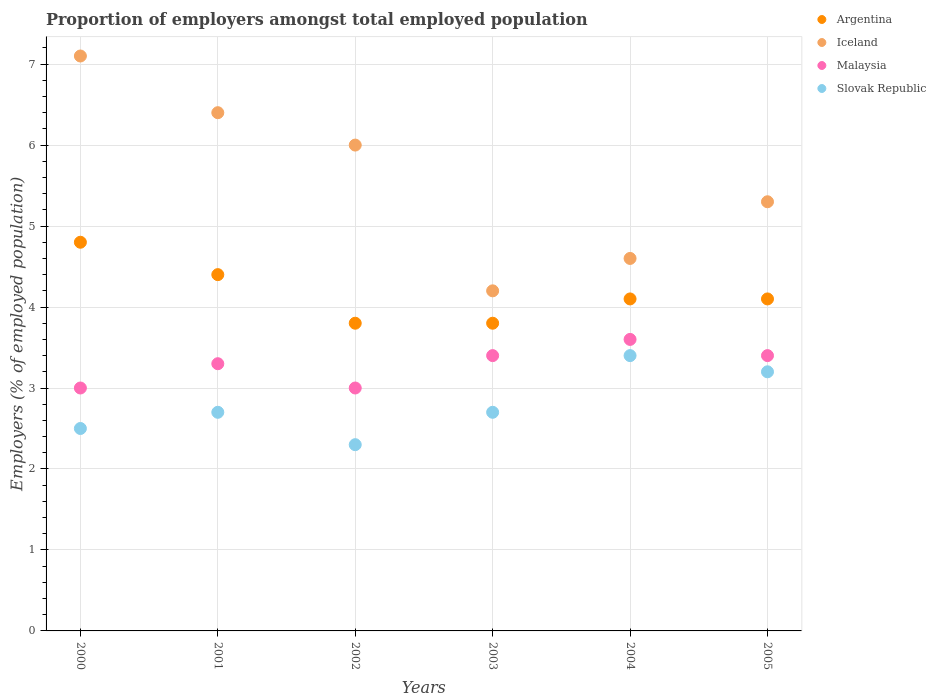Is the number of dotlines equal to the number of legend labels?
Make the answer very short. Yes. What is the proportion of employers in Slovak Republic in 2000?
Provide a short and direct response. 2.5. Across all years, what is the maximum proportion of employers in Slovak Republic?
Give a very brief answer. 3.4. Across all years, what is the minimum proportion of employers in Malaysia?
Offer a very short reply. 3. In which year was the proportion of employers in Iceland maximum?
Your response must be concise. 2000. What is the total proportion of employers in Iceland in the graph?
Give a very brief answer. 33.6. What is the difference between the proportion of employers in Argentina in 2000 and that in 2002?
Provide a succinct answer. 1. What is the difference between the proportion of employers in Iceland in 2000 and the proportion of employers in Argentina in 2001?
Your response must be concise. 2.7. What is the average proportion of employers in Malaysia per year?
Your answer should be compact. 3.28. In the year 2003, what is the difference between the proportion of employers in Slovak Republic and proportion of employers in Iceland?
Your response must be concise. -1.5. In how many years, is the proportion of employers in Slovak Republic greater than 2 %?
Provide a short and direct response. 6. What is the ratio of the proportion of employers in Argentina in 2001 to that in 2005?
Provide a short and direct response. 1.07. Is the proportion of employers in Iceland in 2002 less than that in 2004?
Give a very brief answer. No. What is the difference between the highest and the second highest proportion of employers in Argentina?
Your response must be concise. 0.4. What is the difference between the highest and the lowest proportion of employers in Iceland?
Make the answer very short. 2.9. Is the sum of the proportion of employers in Malaysia in 2001 and 2003 greater than the maximum proportion of employers in Iceland across all years?
Make the answer very short. No. Does the proportion of employers in Iceland monotonically increase over the years?
Provide a succinct answer. No. How many dotlines are there?
Your answer should be very brief. 4. Are the values on the major ticks of Y-axis written in scientific E-notation?
Your response must be concise. No. Does the graph contain any zero values?
Your answer should be very brief. No. Does the graph contain grids?
Offer a very short reply. Yes. What is the title of the graph?
Ensure brevity in your answer.  Proportion of employers amongst total employed population. What is the label or title of the Y-axis?
Your response must be concise. Employers (% of employed population). What is the Employers (% of employed population) of Argentina in 2000?
Offer a very short reply. 4.8. What is the Employers (% of employed population) in Iceland in 2000?
Your answer should be compact. 7.1. What is the Employers (% of employed population) of Malaysia in 2000?
Keep it short and to the point. 3. What is the Employers (% of employed population) of Slovak Republic in 2000?
Your answer should be compact. 2.5. What is the Employers (% of employed population) in Argentina in 2001?
Provide a short and direct response. 4.4. What is the Employers (% of employed population) in Iceland in 2001?
Make the answer very short. 6.4. What is the Employers (% of employed population) in Malaysia in 2001?
Keep it short and to the point. 3.3. What is the Employers (% of employed population) of Slovak Republic in 2001?
Keep it short and to the point. 2.7. What is the Employers (% of employed population) of Argentina in 2002?
Your answer should be very brief. 3.8. What is the Employers (% of employed population) in Iceland in 2002?
Offer a terse response. 6. What is the Employers (% of employed population) in Malaysia in 2002?
Keep it short and to the point. 3. What is the Employers (% of employed population) in Slovak Republic in 2002?
Provide a short and direct response. 2.3. What is the Employers (% of employed population) in Argentina in 2003?
Your answer should be very brief. 3.8. What is the Employers (% of employed population) of Iceland in 2003?
Keep it short and to the point. 4.2. What is the Employers (% of employed population) in Malaysia in 2003?
Your response must be concise. 3.4. What is the Employers (% of employed population) in Slovak Republic in 2003?
Your response must be concise. 2.7. What is the Employers (% of employed population) of Argentina in 2004?
Offer a very short reply. 4.1. What is the Employers (% of employed population) of Iceland in 2004?
Keep it short and to the point. 4.6. What is the Employers (% of employed population) of Malaysia in 2004?
Your answer should be compact. 3.6. What is the Employers (% of employed population) in Slovak Republic in 2004?
Offer a very short reply. 3.4. What is the Employers (% of employed population) in Argentina in 2005?
Provide a succinct answer. 4.1. What is the Employers (% of employed population) in Iceland in 2005?
Your answer should be compact. 5.3. What is the Employers (% of employed population) of Malaysia in 2005?
Keep it short and to the point. 3.4. What is the Employers (% of employed population) of Slovak Republic in 2005?
Make the answer very short. 3.2. Across all years, what is the maximum Employers (% of employed population) of Argentina?
Your answer should be very brief. 4.8. Across all years, what is the maximum Employers (% of employed population) in Iceland?
Give a very brief answer. 7.1. Across all years, what is the maximum Employers (% of employed population) of Malaysia?
Provide a short and direct response. 3.6. Across all years, what is the maximum Employers (% of employed population) of Slovak Republic?
Your answer should be very brief. 3.4. Across all years, what is the minimum Employers (% of employed population) of Argentina?
Your response must be concise. 3.8. Across all years, what is the minimum Employers (% of employed population) in Iceland?
Ensure brevity in your answer.  4.2. Across all years, what is the minimum Employers (% of employed population) in Malaysia?
Your response must be concise. 3. Across all years, what is the minimum Employers (% of employed population) in Slovak Republic?
Provide a short and direct response. 2.3. What is the total Employers (% of employed population) of Iceland in the graph?
Give a very brief answer. 33.6. What is the difference between the Employers (% of employed population) in Argentina in 2000 and that in 2001?
Keep it short and to the point. 0.4. What is the difference between the Employers (% of employed population) of Slovak Republic in 2000 and that in 2001?
Offer a terse response. -0.2. What is the difference between the Employers (% of employed population) of Malaysia in 2000 and that in 2002?
Provide a short and direct response. 0. What is the difference between the Employers (% of employed population) of Iceland in 2000 and that in 2003?
Provide a short and direct response. 2.9. What is the difference between the Employers (% of employed population) of Malaysia in 2000 and that in 2003?
Provide a short and direct response. -0.4. What is the difference between the Employers (% of employed population) of Argentina in 2000 and that in 2005?
Make the answer very short. 0.7. What is the difference between the Employers (% of employed population) of Malaysia in 2000 and that in 2005?
Offer a very short reply. -0.4. What is the difference between the Employers (% of employed population) in Slovak Republic in 2000 and that in 2005?
Offer a terse response. -0.7. What is the difference between the Employers (% of employed population) in Argentina in 2001 and that in 2002?
Your answer should be very brief. 0.6. What is the difference between the Employers (% of employed population) of Iceland in 2001 and that in 2002?
Your response must be concise. 0.4. What is the difference between the Employers (% of employed population) in Malaysia in 2001 and that in 2003?
Offer a very short reply. -0.1. What is the difference between the Employers (% of employed population) in Slovak Republic in 2001 and that in 2003?
Your answer should be compact. 0. What is the difference between the Employers (% of employed population) in Iceland in 2001 and that in 2004?
Keep it short and to the point. 1.8. What is the difference between the Employers (% of employed population) of Malaysia in 2001 and that in 2004?
Your response must be concise. -0.3. What is the difference between the Employers (% of employed population) of Slovak Republic in 2001 and that in 2004?
Your answer should be very brief. -0.7. What is the difference between the Employers (% of employed population) in Argentina in 2001 and that in 2005?
Provide a short and direct response. 0.3. What is the difference between the Employers (% of employed population) in Argentina in 2002 and that in 2003?
Ensure brevity in your answer.  0. What is the difference between the Employers (% of employed population) of Iceland in 2002 and that in 2003?
Your answer should be very brief. 1.8. What is the difference between the Employers (% of employed population) of Slovak Republic in 2002 and that in 2003?
Provide a short and direct response. -0.4. What is the difference between the Employers (% of employed population) in Malaysia in 2002 and that in 2004?
Your response must be concise. -0.6. What is the difference between the Employers (% of employed population) in Argentina in 2002 and that in 2005?
Keep it short and to the point. -0.3. What is the difference between the Employers (% of employed population) in Iceland in 2002 and that in 2005?
Provide a succinct answer. 0.7. What is the difference between the Employers (% of employed population) of Slovak Republic in 2002 and that in 2005?
Ensure brevity in your answer.  -0.9. What is the difference between the Employers (% of employed population) of Iceland in 2003 and that in 2004?
Your answer should be compact. -0.4. What is the difference between the Employers (% of employed population) in Argentina in 2003 and that in 2005?
Keep it short and to the point. -0.3. What is the difference between the Employers (% of employed population) in Malaysia in 2003 and that in 2005?
Make the answer very short. 0. What is the difference between the Employers (% of employed population) of Iceland in 2004 and that in 2005?
Keep it short and to the point. -0.7. What is the difference between the Employers (% of employed population) of Malaysia in 2004 and that in 2005?
Give a very brief answer. 0.2. What is the difference between the Employers (% of employed population) in Slovak Republic in 2004 and that in 2005?
Keep it short and to the point. 0.2. What is the difference between the Employers (% of employed population) of Iceland in 2000 and the Employers (% of employed population) of Malaysia in 2001?
Give a very brief answer. 3.8. What is the difference between the Employers (% of employed population) of Argentina in 2000 and the Employers (% of employed population) of Iceland in 2002?
Give a very brief answer. -1.2. What is the difference between the Employers (% of employed population) of Argentina in 2000 and the Employers (% of employed population) of Malaysia in 2002?
Provide a short and direct response. 1.8. What is the difference between the Employers (% of employed population) of Argentina in 2000 and the Employers (% of employed population) of Slovak Republic in 2002?
Your response must be concise. 2.5. What is the difference between the Employers (% of employed population) of Iceland in 2000 and the Employers (% of employed population) of Malaysia in 2002?
Your answer should be very brief. 4.1. What is the difference between the Employers (% of employed population) in Iceland in 2000 and the Employers (% of employed population) in Slovak Republic in 2002?
Ensure brevity in your answer.  4.8. What is the difference between the Employers (% of employed population) in Malaysia in 2000 and the Employers (% of employed population) in Slovak Republic in 2002?
Ensure brevity in your answer.  0.7. What is the difference between the Employers (% of employed population) of Argentina in 2000 and the Employers (% of employed population) of Iceland in 2003?
Give a very brief answer. 0.6. What is the difference between the Employers (% of employed population) of Argentina in 2000 and the Employers (% of employed population) of Iceland in 2004?
Offer a terse response. 0.2. What is the difference between the Employers (% of employed population) of Argentina in 2000 and the Employers (% of employed population) of Slovak Republic in 2004?
Make the answer very short. 1.4. What is the difference between the Employers (% of employed population) in Iceland in 2000 and the Employers (% of employed population) in Malaysia in 2004?
Keep it short and to the point. 3.5. What is the difference between the Employers (% of employed population) in Argentina in 2000 and the Employers (% of employed population) in Malaysia in 2005?
Ensure brevity in your answer.  1.4. What is the difference between the Employers (% of employed population) in Iceland in 2000 and the Employers (% of employed population) in Malaysia in 2005?
Ensure brevity in your answer.  3.7. What is the difference between the Employers (% of employed population) of Iceland in 2000 and the Employers (% of employed population) of Slovak Republic in 2005?
Offer a very short reply. 3.9. What is the difference between the Employers (% of employed population) of Iceland in 2001 and the Employers (% of employed population) of Malaysia in 2002?
Offer a very short reply. 3.4. What is the difference between the Employers (% of employed population) in Malaysia in 2001 and the Employers (% of employed population) in Slovak Republic in 2002?
Your response must be concise. 1. What is the difference between the Employers (% of employed population) of Argentina in 2001 and the Employers (% of employed population) of Iceland in 2003?
Keep it short and to the point. 0.2. What is the difference between the Employers (% of employed population) of Argentina in 2001 and the Employers (% of employed population) of Slovak Republic in 2003?
Your answer should be very brief. 1.7. What is the difference between the Employers (% of employed population) in Iceland in 2001 and the Employers (% of employed population) in Malaysia in 2003?
Provide a succinct answer. 3. What is the difference between the Employers (% of employed population) in Malaysia in 2001 and the Employers (% of employed population) in Slovak Republic in 2003?
Your answer should be very brief. 0.6. What is the difference between the Employers (% of employed population) in Argentina in 2001 and the Employers (% of employed population) in Malaysia in 2004?
Ensure brevity in your answer.  0.8. What is the difference between the Employers (% of employed population) of Argentina in 2001 and the Employers (% of employed population) of Iceland in 2005?
Ensure brevity in your answer.  -0.9. What is the difference between the Employers (% of employed population) in Argentina in 2001 and the Employers (% of employed population) in Slovak Republic in 2005?
Keep it short and to the point. 1.2. What is the difference between the Employers (% of employed population) of Iceland in 2001 and the Employers (% of employed population) of Slovak Republic in 2005?
Keep it short and to the point. 3.2. What is the difference between the Employers (% of employed population) in Malaysia in 2001 and the Employers (% of employed population) in Slovak Republic in 2005?
Your response must be concise. 0.1. What is the difference between the Employers (% of employed population) of Argentina in 2002 and the Employers (% of employed population) of Iceland in 2003?
Offer a terse response. -0.4. What is the difference between the Employers (% of employed population) in Iceland in 2002 and the Employers (% of employed population) in Malaysia in 2003?
Give a very brief answer. 2.6. What is the difference between the Employers (% of employed population) of Iceland in 2002 and the Employers (% of employed population) of Slovak Republic in 2004?
Your answer should be compact. 2.6. What is the difference between the Employers (% of employed population) of Argentina in 2002 and the Employers (% of employed population) of Malaysia in 2005?
Make the answer very short. 0.4. What is the difference between the Employers (% of employed population) in Iceland in 2002 and the Employers (% of employed population) in Malaysia in 2005?
Ensure brevity in your answer.  2.6. What is the difference between the Employers (% of employed population) of Argentina in 2003 and the Employers (% of employed population) of Iceland in 2004?
Your answer should be very brief. -0.8. What is the difference between the Employers (% of employed population) of Argentina in 2003 and the Employers (% of employed population) of Malaysia in 2004?
Ensure brevity in your answer.  0.2. What is the difference between the Employers (% of employed population) of Iceland in 2003 and the Employers (% of employed population) of Slovak Republic in 2004?
Ensure brevity in your answer.  0.8. What is the difference between the Employers (% of employed population) in Argentina in 2003 and the Employers (% of employed population) in Iceland in 2005?
Provide a succinct answer. -1.5. What is the difference between the Employers (% of employed population) in Argentina in 2004 and the Employers (% of employed population) in Malaysia in 2005?
Your answer should be very brief. 0.7. What is the difference between the Employers (% of employed population) of Argentina in 2004 and the Employers (% of employed population) of Slovak Republic in 2005?
Provide a succinct answer. 0.9. What is the difference between the Employers (% of employed population) in Iceland in 2004 and the Employers (% of employed population) in Malaysia in 2005?
Your response must be concise. 1.2. What is the difference between the Employers (% of employed population) of Iceland in 2004 and the Employers (% of employed population) of Slovak Republic in 2005?
Ensure brevity in your answer.  1.4. What is the average Employers (% of employed population) of Argentina per year?
Offer a very short reply. 4.17. What is the average Employers (% of employed population) in Malaysia per year?
Keep it short and to the point. 3.28. What is the average Employers (% of employed population) of Slovak Republic per year?
Give a very brief answer. 2.8. In the year 2000, what is the difference between the Employers (% of employed population) of Argentina and Employers (% of employed population) of Iceland?
Your response must be concise. -2.3. In the year 2000, what is the difference between the Employers (% of employed population) of Argentina and Employers (% of employed population) of Malaysia?
Provide a succinct answer. 1.8. In the year 2001, what is the difference between the Employers (% of employed population) in Iceland and Employers (% of employed population) in Malaysia?
Provide a succinct answer. 3.1. In the year 2001, what is the difference between the Employers (% of employed population) in Iceland and Employers (% of employed population) in Slovak Republic?
Provide a short and direct response. 3.7. In the year 2001, what is the difference between the Employers (% of employed population) of Malaysia and Employers (% of employed population) of Slovak Republic?
Your answer should be compact. 0.6. In the year 2002, what is the difference between the Employers (% of employed population) of Argentina and Employers (% of employed population) of Slovak Republic?
Ensure brevity in your answer.  1.5. In the year 2002, what is the difference between the Employers (% of employed population) of Iceland and Employers (% of employed population) of Malaysia?
Provide a short and direct response. 3. In the year 2003, what is the difference between the Employers (% of employed population) in Argentina and Employers (% of employed population) in Iceland?
Provide a succinct answer. -0.4. In the year 2003, what is the difference between the Employers (% of employed population) of Argentina and Employers (% of employed population) of Malaysia?
Provide a succinct answer. 0.4. In the year 2003, what is the difference between the Employers (% of employed population) in Argentina and Employers (% of employed population) in Slovak Republic?
Offer a terse response. 1.1. In the year 2003, what is the difference between the Employers (% of employed population) of Malaysia and Employers (% of employed population) of Slovak Republic?
Offer a terse response. 0.7. In the year 2004, what is the difference between the Employers (% of employed population) in Argentina and Employers (% of employed population) in Iceland?
Offer a very short reply. -0.5. In the year 2004, what is the difference between the Employers (% of employed population) of Iceland and Employers (% of employed population) of Malaysia?
Make the answer very short. 1. What is the ratio of the Employers (% of employed population) of Argentina in 2000 to that in 2001?
Provide a succinct answer. 1.09. What is the ratio of the Employers (% of employed population) in Iceland in 2000 to that in 2001?
Your response must be concise. 1.11. What is the ratio of the Employers (% of employed population) in Slovak Republic in 2000 to that in 2001?
Provide a succinct answer. 0.93. What is the ratio of the Employers (% of employed population) in Argentina in 2000 to that in 2002?
Provide a succinct answer. 1.26. What is the ratio of the Employers (% of employed population) in Iceland in 2000 to that in 2002?
Provide a short and direct response. 1.18. What is the ratio of the Employers (% of employed population) in Slovak Republic in 2000 to that in 2002?
Offer a terse response. 1.09. What is the ratio of the Employers (% of employed population) of Argentina in 2000 to that in 2003?
Make the answer very short. 1.26. What is the ratio of the Employers (% of employed population) in Iceland in 2000 to that in 2003?
Provide a succinct answer. 1.69. What is the ratio of the Employers (% of employed population) of Malaysia in 2000 to that in 2003?
Offer a terse response. 0.88. What is the ratio of the Employers (% of employed population) of Slovak Republic in 2000 to that in 2003?
Ensure brevity in your answer.  0.93. What is the ratio of the Employers (% of employed population) in Argentina in 2000 to that in 2004?
Give a very brief answer. 1.17. What is the ratio of the Employers (% of employed population) of Iceland in 2000 to that in 2004?
Make the answer very short. 1.54. What is the ratio of the Employers (% of employed population) in Slovak Republic in 2000 to that in 2004?
Ensure brevity in your answer.  0.74. What is the ratio of the Employers (% of employed population) in Argentina in 2000 to that in 2005?
Give a very brief answer. 1.17. What is the ratio of the Employers (% of employed population) in Iceland in 2000 to that in 2005?
Offer a terse response. 1.34. What is the ratio of the Employers (% of employed population) of Malaysia in 2000 to that in 2005?
Make the answer very short. 0.88. What is the ratio of the Employers (% of employed population) of Slovak Republic in 2000 to that in 2005?
Keep it short and to the point. 0.78. What is the ratio of the Employers (% of employed population) of Argentina in 2001 to that in 2002?
Ensure brevity in your answer.  1.16. What is the ratio of the Employers (% of employed population) in Iceland in 2001 to that in 2002?
Your answer should be very brief. 1.07. What is the ratio of the Employers (% of employed population) in Malaysia in 2001 to that in 2002?
Your answer should be compact. 1.1. What is the ratio of the Employers (% of employed population) of Slovak Republic in 2001 to that in 2002?
Your response must be concise. 1.17. What is the ratio of the Employers (% of employed population) of Argentina in 2001 to that in 2003?
Provide a short and direct response. 1.16. What is the ratio of the Employers (% of employed population) in Iceland in 2001 to that in 2003?
Keep it short and to the point. 1.52. What is the ratio of the Employers (% of employed population) in Malaysia in 2001 to that in 2003?
Ensure brevity in your answer.  0.97. What is the ratio of the Employers (% of employed population) in Argentina in 2001 to that in 2004?
Provide a succinct answer. 1.07. What is the ratio of the Employers (% of employed population) of Iceland in 2001 to that in 2004?
Make the answer very short. 1.39. What is the ratio of the Employers (% of employed population) of Slovak Republic in 2001 to that in 2004?
Ensure brevity in your answer.  0.79. What is the ratio of the Employers (% of employed population) of Argentina in 2001 to that in 2005?
Offer a very short reply. 1.07. What is the ratio of the Employers (% of employed population) of Iceland in 2001 to that in 2005?
Give a very brief answer. 1.21. What is the ratio of the Employers (% of employed population) in Malaysia in 2001 to that in 2005?
Provide a short and direct response. 0.97. What is the ratio of the Employers (% of employed population) of Slovak Republic in 2001 to that in 2005?
Offer a very short reply. 0.84. What is the ratio of the Employers (% of employed population) in Iceland in 2002 to that in 2003?
Provide a short and direct response. 1.43. What is the ratio of the Employers (% of employed population) in Malaysia in 2002 to that in 2003?
Provide a succinct answer. 0.88. What is the ratio of the Employers (% of employed population) of Slovak Republic in 2002 to that in 2003?
Offer a very short reply. 0.85. What is the ratio of the Employers (% of employed population) of Argentina in 2002 to that in 2004?
Provide a short and direct response. 0.93. What is the ratio of the Employers (% of employed population) of Iceland in 2002 to that in 2004?
Provide a short and direct response. 1.3. What is the ratio of the Employers (% of employed population) of Slovak Republic in 2002 to that in 2004?
Give a very brief answer. 0.68. What is the ratio of the Employers (% of employed population) in Argentina in 2002 to that in 2005?
Keep it short and to the point. 0.93. What is the ratio of the Employers (% of employed population) in Iceland in 2002 to that in 2005?
Your answer should be very brief. 1.13. What is the ratio of the Employers (% of employed population) in Malaysia in 2002 to that in 2005?
Give a very brief answer. 0.88. What is the ratio of the Employers (% of employed population) in Slovak Republic in 2002 to that in 2005?
Your answer should be very brief. 0.72. What is the ratio of the Employers (% of employed population) in Argentina in 2003 to that in 2004?
Your answer should be compact. 0.93. What is the ratio of the Employers (% of employed population) in Iceland in 2003 to that in 2004?
Provide a succinct answer. 0.91. What is the ratio of the Employers (% of employed population) of Slovak Republic in 2003 to that in 2004?
Keep it short and to the point. 0.79. What is the ratio of the Employers (% of employed population) in Argentina in 2003 to that in 2005?
Ensure brevity in your answer.  0.93. What is the ratio of the Employers (% of employed population) in Iceland in 2003 to that in 2005?
Your answer should be very brief. 0.79. What is the ratio of the Employers (% of employed population) of Slovak Republic in 2003 to that in 2005?
Provide a succinct answer. 0.84. What is the ratio of the Employers (% of employed population) in Argentina in 2004 to that in 2005?
Your answer should be very brief. 1. What is the ratio of the Employers (% of employed population) of Iceland in 2004 to that in 2005?
Your response must be concise. 0.87. What is the ratio of the Employers (% of employed population) in Malaysia in 2004 to that in 2005?
Give a very brief answer. 1.06. What is the difference between the highest and the second highest Employers (% of employed population) of Malaysia?
Make the answer very short. 0.2. What is the difference between the highest and the lowest Employers (% of employed population) of Argentina?
Provide a succinct answer. 1. What is the difference between the highest and the lowest Employers (% of employed population) of Iceland?
Offer a terse response. 2.9. 